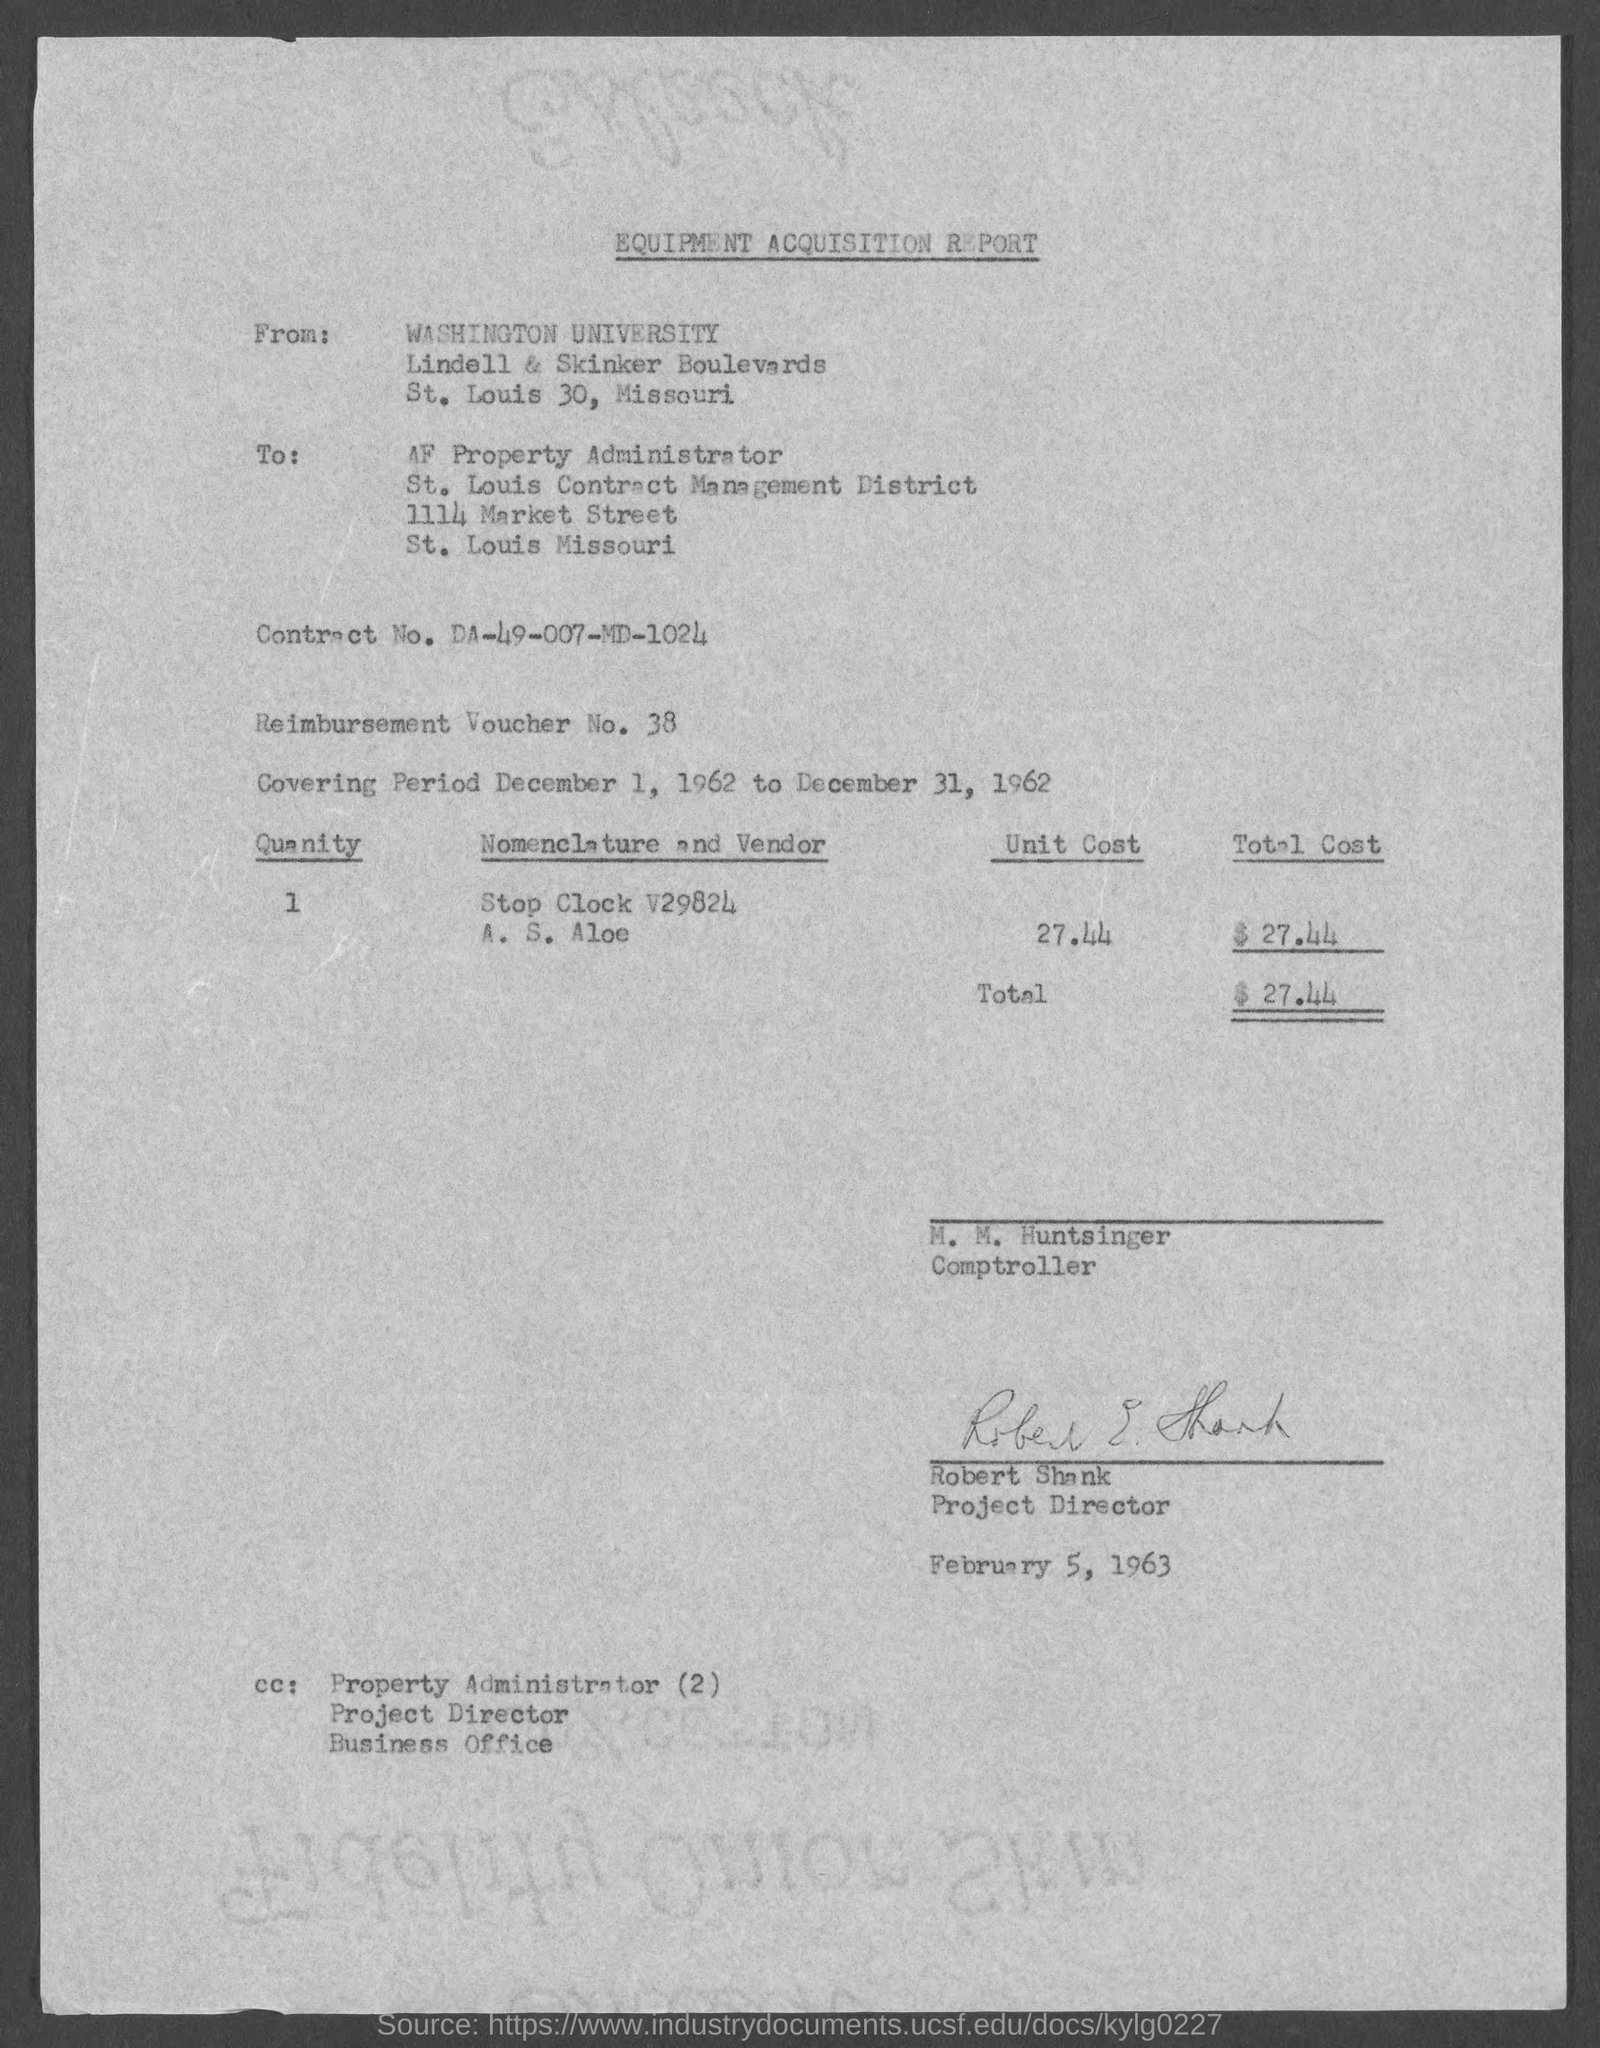Specify some key components in this picture. The currency is $.. The report was written by Washington University. This is a reimbursement voucher numbered 38... 